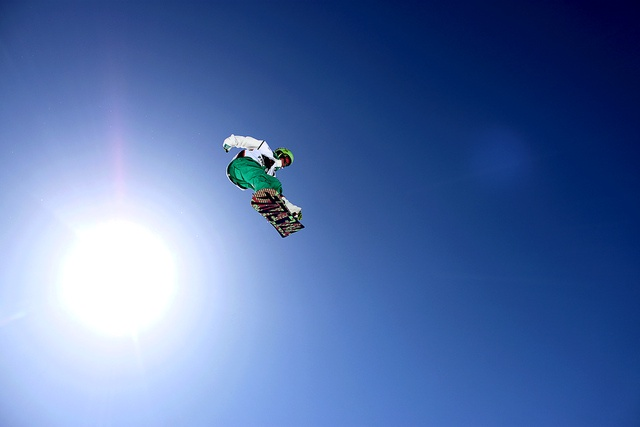Describe the objects in this image and their specific colors. I can see people in navy, lightgray, teal, and black tones and snowboard in navy, black, gray, maroon, and brown tones in this image. 